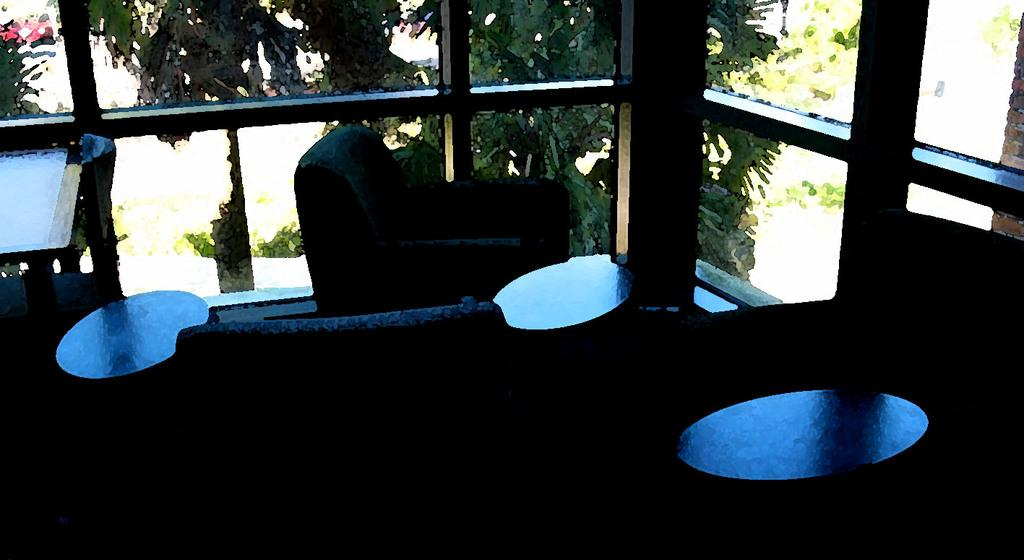What type of furniture is present in the image? There are tables and sofas in the image. Where are the tables and sofas located? The tables and sofas are on the floor. What can be seen in the background of the image? There are glass windows and trees visible in the background of the image. What type of shock can be seen coming from the wire in the image? There is no wire present in the image, so it is not possible to determine if there is any shock or not. 